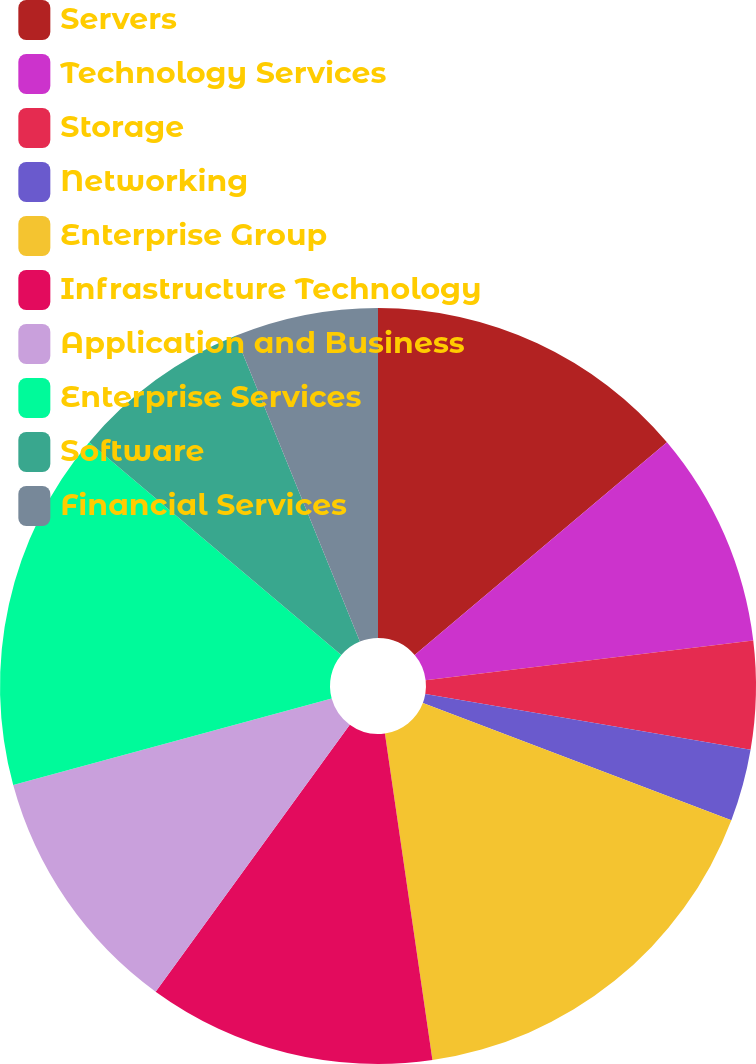Convert chart to OTSL. <chart><loc_0><loc_0><loc_500><loc_500><pie_chart><fcel>Servers<fcel>Technology Services<fcel>Storage<fcel>Networking<fcel>Enterprise Group<fcel>Infrastructure Technology<fcel>Application and Business<fcel>Enterprise Services<fcel>Software<fcel>Financial Services<nl><fcel>13.85%<fcel>9.23%<fcel>4.62%<fcel>3.08%<fcel>16.92%<fcel>12.31%<fcel>10.77%<fcel>15.38%<fcel>7.69%<fcel>6.15%<nl></chart> 